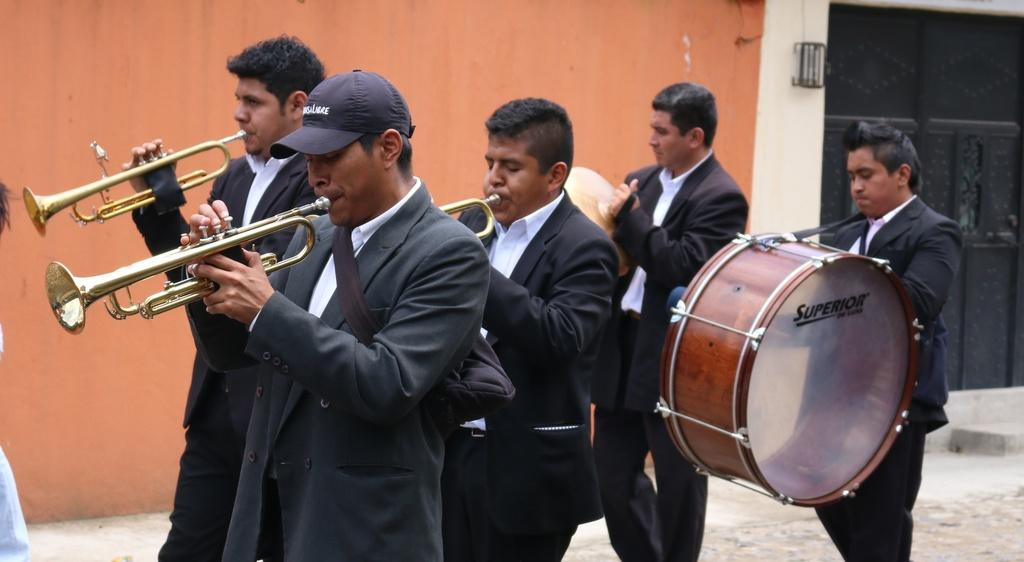What are the people on the floor in the image doing? The people on the floor in the image are holding musical instruments. What can be seen in the background of the image? There is a wall in the background of the image. Can you describe the person on the left side of the image? There is a person wearing a cap on the left side of the image. What type of cake is being served to the people in the image? There is no cake present in the image; the people are holding musical instruments. Can you tell me how many bats are flying around in the image? There are no bats present in the image; it features people holding musical instruments. 